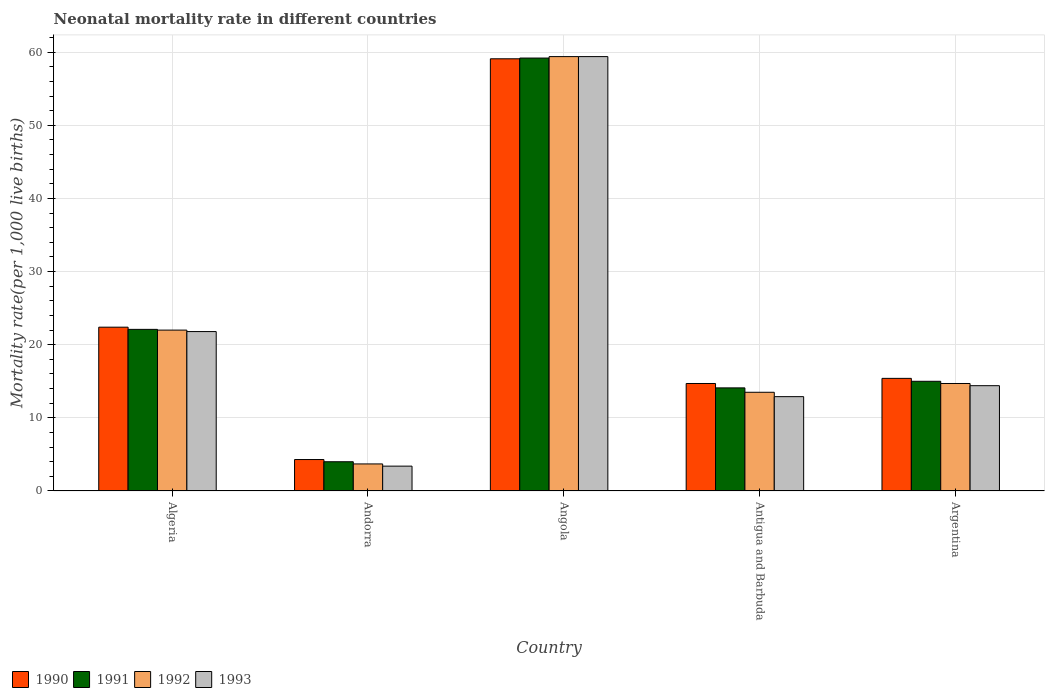How many different coloured bars are there?
Offer a very short reply. 4. How many groups of bars are there?
Offer a very short reply. 5. Are the number of bars on each tick of the X-axis equal?
Offer a very short reply. Yes. What is the label of the 1st group of bars from the left?
Make the answer very short. Algeria. What is the neonatal mortality rate in 1993 in Algeria?
Make the answer very short. 21.8. Across all countries, what is the maximum neonatal mortality rate in 1991?
Offer a very short reply. 59.2. In which country was the neonatal mortality rate in 1990 maximum?
Keep it short and to the point. Angola. In which country was the neonatal mortality rate in 1992 minimum?
Provide a succinct answer. Andorra. What is the total neonatal mortality rate in 1991 in the graph?
Offer a very short reply. 114.4. What is the difference between the neonatal mortality rate in 1992 in Algeria and that in Antigua and Barbuda?
Ensure brevity in your answer.  8.5. What is the difference between the neonatal mortality rate in 1993 in Angola and the neonatal mortality rate in 1992 in Antigua and Barbuda?
Your response must be concise. 45.9. What is the average neonatal mortality rate in 1993 per country?
Your response must be concise. 22.38. What is the difference between the neonatal mortality rate of/in 1990 and neonatal mortality rate of/in 1992 in Andorra?
Offer a terse response. 0.6. What is the ratio of the neonatal mortality rate in 1990 in Algeria to that in Andorra?
Provide a succinct answer. 5.21. Is the neonatal mortality rate in 1993 in Algeria less than that in Andorra?
Make the answer very short. No. Is the difference between the neonatal mortality rate in 1990 in Andorra and Antigua and Barbuda greater than the difference between the neonatal mortality rate in 1992 in Andorra and Antigua and Barbuda?
Your answer should be compact. No. What is the difference between the highest and the second highest neonatal mortality rate in 1993?
Ensure brevity in your answer.  37.6. What is the difference between the highest and the lowest neonatal mortality rate in 1992?
Make the answer very short. 55.7. What does the 1st bar from the left in Antigua and Barbuda represents?
Your answer should be very brief. 1990. What does the 2nd bar from the right in Angola represents?
Offer a terse response. 1992. How many bars are there?
Provide a succinct answer. 20. Are all the bars in the graph horizontal?
Make the answer very short. No. Are the values on the major ticks of Y-axis written in scientific E-notation?
Give a very brief answer. No. Does the graph contain any zero values?
Ensure brevity in your answer.  No. Does the graph contain grids?
Your response must be concise. Yes. How many legend labels are there?
Offer a terse response. 4. What is the title of the graph?
Ensure brevity in your answer.  Neonatal mortality rate in different countries. What is the label or title of the Y-axis?
Provide a short and direct response. Mortality rate(per 1,0 live births). What is the Mortality rate(per 1,000 live births) of 1990 in Algeria?
Give a very brief answer. 22.4. What is the Mortality rate(per 1,000 live births) of 1991 in Algeria?
Offer a very short reply. 22.1. What is the Mortality rate(per 1,000 live births) of 1993 in Algeria?
Offer a very short reply. 21.8. What is the Mortality rate(per 1,000 live births) of 1990 in Andorra?
Offer a very short reply. 4.3. What is the Mortality rate(per 1,000 live births) of 1990 in Angola?
Make the answer very short. 59.1. What is the Mortality rate(per 1,000 live births) of 1991 in Angola?
Your answer should be compact. 59.2. What is the Mortality rate(per 1,000 live births) of 1992 in Angola?
Your answer should be very brief. 59.4. What is the Mortality rate(per 1,000 live births) of 1993 in Angola?
Keep it short and to the point. 59.4. What is the Mortality rate(per 1,000 live births) in 1993 in Antigua and Barbuda?
Your answer should be compact. 12.9. What is the Mortality rate(per 1,000 live births) of 1991 in Argentina?
Provide a short and direct response. 15. What is the Mortality rate(per 1,000 live births) in 1993 in Argentina?
Your answer should be compact. 14.4. Across all countries, what is the maximum Mortality rate(per 1,000 live births) in 1990?
Your answer should be very brief. 59.1. Across all countries, what is the maximum Mortality rate(per 1,000 live births) in 1991?
Provide a short and direct response. 59.2. Across all countries, what is the maximum Mortality rate(per 1,000 live births) in 1992?
Your answer should be compact. 59.4. Across all countries, what is the maximum Mortality rate(per 1,000 live births) of 1993?
Offer a terse response. 59.4. Across all countries, what is the minimum Mortality rate(per 1,000 live births) of 1990?
Give a very brief answer. 4.3. Across all countries, what is the minimum Mortality rate(per 1,000 live births) of 1992?
Offer a very short reply. 3.7. What is the total Mortality rate(per 1,000 live births) of 1990 in the graph?
Provide a succinct answer. 115.9. What is the total Mortality rate(per 1,000 live births) in 1991 in the graph?
Your answer should be compact. 114.4. What is the total Mortality rate(per 1,000 live births) in 1992 in the graph?
Your answer should be compact. 113.3. What is the total Mortality rate(per 1,000 live births) in 1993 in the graph?
Provide a succinct answer. 111.9. What is the difference between the Mortality rate(per 1,000 live births) in 1990 in Algeria and that in Andorra?
Make the answer very short. 18.1. What is the difference between the Mortality rate(per 1,000 live births) in 1991 in Algeria and that in Andorra?
Offer a terse response. 18.1. What is the difference between the Mortality rate(per 1,000 live births) of 1993 in Algeria and that in Andorra?
Your answer should be very brief. 18.4. What is the difference between the Mortality rate(per 1,000 live births) in 1990 in Algeria and that in Angola?
Your answer should be compact. -36.7. What is the difference between the Mortality rate(per 1,000 live births) of 1991 in Algeria and that in Angola?
Provide a succinct answer. -37.1. What is the difference between the Mortality rate(per 1,000 live births) of 1992 in Algeria and that in Angola?
Give a very brief answer. -37.4. What is the difference between the Mortality rate(per 1,000 live births) in 1993 in Algeria and that in Angola?
Your answer should be compact. -37.6. What is the difference between the Mortality rate(per 1,000 live births) of 1991 in Algeria and that in Antigua and Barbuda?
Keep it short and to the point. 8. What is the difference between the Mortality rate(per 1,000 live births) of 1993 in Algeria and that in Antigua and Barbuda?
Your response must be concise. 8.9. What is the difference between the Mortality rate(per 1,000 live births) of 1992 in Algeria and that in Argentina?
Keep it short and to the point. 7.3. What is the difference between the Mortality rate(per 1,000 live births) in 1990 in Andorra and that in Angola?
Ensure brevity in your answer.  -54.8. What is the difference between the Mortality rate(per 1,000 live births) of 1991 in Andorra and that in Angola?
Give a very brief answer. -55.2. What is the difference between the Mortality rate(per 1,000 live births) in 1992 in Andorra and that in Angola?
Your response must be concise. -55.7. What is the difference between the Mortality rate(per 1,000 live births) in 1993 in Andorra and that in Angola?
Make the answer very short. -56. What is the difference between the Mortality rate(per 1,000 live births) in 1990 in Andorra and that in Antigua and Barbuda?
Your answer should be compact. -10.4. What is the difference between the Mortality rate(per 1,000 live births) of 1991 in Andorra and that in Antigua and Barbuda?
Your response must be concise. -10.1. What is the difference between the Mortality rate(per 1,000 live births) in 1993 in Andorra and that in Antigua and Barbuda?
Provide a succinct answer. -9.5. What is the difference between the Mortality rate(per 1,000 live births) of 1990 in Andorra and that in Argentina?
Provide a short and direct response. -11.1. What is the difference between the Mortality rate(per 1,000 live births) in 1993 in Andorra and that in Argentina?
Give a very brief answer. -11. What is the difference between the Mortality rate(per 1,000 live births) in 1990 in Angola and that in Antigua and Barbuda?
Provide a succinct answer. 44.4. What is the difference between the Mortality rate(per 1,000 live births) in 1991 in Angola and that in Antigua and Barbuda?
Offer a very short reply. 45.1. What is the difference between the Mortality rate(per 1,000 live births) in 1992 in Angola and that in Antigua and Barbuda?
Your response must be concise. 45.9. What is the difference between the Mortality rate(per 1,000 live births) of 1993 in Angola and that in Antigua and Barbuda?
Make the answer very short. 46.5. What is the difference between the Mortality rate(per 1,000 live births) of 1990 in Angola and that in Argentina?
Provide a succinct answer. 43.7. What is the difference between the Mortality rate(per 1,000 live births) of 1991 in Angola and that in Argentina?
Your answer should be compact. 44.2. What is the difference between the Mortality rate(per 1,000 live births) in 1992 in Angola and that in Argentina?
Give a very brief answer. 44.7. What is the difference between the Mortality rate(per 1,000 live births) in 1991 in Antigua and Barbuda and that in Argentina?
Provide a short and direct response. -0.9. What is the difference between the Mortality rate(per 1,000 live births) of 1993 in Antigua and Barbuda and that in Argentina?
Your answer should be very brief. -1.5. What is the difference between the Mortality rate(per 1,000 live births) in 1990 in Algeria and the Mortality rate(per 1,000 live births) in 1991 in Andorra?
Your answer should be very brief. 18.4. What is the difference between the Mortality rate(per 1,000 live births) of 1991 in Algeria and the Mortality rate(per 1,000 live births) of 1993 in Andorra?
Give a very brief answer. 18.7. What is the difference between the Mortality rate(per 1,000 live births) of 1990 in Algeria and the Mortality rate(per 1,000 live births) of 1991 in Angola?
Your answer should be compact. -36.8. What is the difference between the Mortality rate(per 1,000 live births) in 1990 in Algeria and the Mortality rate(per 1,000 live births) in 1992 in Angola?
Make the answer very short. -37. What is the difference between the Mortality rate(per 1,000 live births) of 1990 in Algeria and the Mortality rate(per 1,000 live births) of 1993 in Angola?
Your response must be concise. -37. What is the difference between the Mortality rate(per 1,000 live births) in 1991 in Algeria and the Mortality rate(per 1,000 live births) in 1992 in Angola?
Ensure brevity in your answer.  -37.3. What is the difference between the Mortality rate(per 1,000 live births) of 1991 in Algeria and the Mortality rate(per 1,000 live births) of 1993 in Angola?
Provide a succinct answer. -37.3. What is the difference between the Mortality rate(per 1,000 live births) in 1992 in Algeria and the Mortality rate(per 1,000 live births) in 1993 in Angola?
Your answer should be very brief. -37.4. What is the difference between the Mortality rate(per 1,000 live births) of 1991 in Algeria and the Mortality rate(per 1,000 live births) of 1993 in Antigua and Barbuda?
Offer a terse response. 9.2. What is the difference between the Mortality rate(per 1,000 live births) in 1992 in Algeria and the Mortality rate(per 1,000 live births) in 1993 in Antigua and Barbuda?
Give a very brief answer. 9.1. What is the difference between the Mortality rate(per 1,000 live births) in 1990 in Algeria and the Mortality rate(per 1,000 live births) in 1991 in Argentina?
Provide a succinct answer. 7.4. What is the difference between the Mortality rate(per 1,000 live births) of 1990 in Algeria and the Mortality rate(per 1,000 live births) of 1993 in Argentina?
Your response must be concise. 8. What is the difference between the Mortality rate(per 1,000 live births) in 1991 in Algeria and the Mortality rate(per 1,000 live births) in 1993 in Argentina?
Give a very brief answer. 7.7. What is the difference between the Mortality rate(per 1,000 live births) in 1992 in Algeria and the Mortality rate(per 1,000 live births) in 1993 in Argentina?
Keep it short and to the point. 7.6. What is the difference between the Mortality rate(per 1,000 live births) in 1990 in Andorra and the Mortality rate(per 1,000 live births) in 1991 in Angola?
Provide a short and direct response. -54.9. What is the difference between the Mortality rate(per 1,000 live births) in 1990 in Andorra and the Mortality rate(per 1,000 live births) in 1992 in Angola?
Keep it short and to the point. -55.1. What is the difference between the Mortality rate(per 1,000 live births) in 1990 in Andorra and the Mortality rate(per 1,000 live births) in 1993 in Angola?
Provide a succinct answer. -55.1. What is the difference between the Mortality rate(per 1,000 live births) in 1991 in Andorra and the Mortality rate(per 1,000 live births) in 1992 in Angola?
Your response must be concise. -55.4. What is the difference between the Mortality rate(per 1,000 live births) of 1991 in Andorra and the Mortality rate(per 1,000 live births) of 1993 in Angola?
Give a very brief answer. -55.4. What is the difference between the Mortality rate(per 1,000 live births) in 1992 in Andorra and the Mortality rate(per 1,000 live births) in 1993 in Angola?
Give a very brief answer. -55.7. What is the difference between the Mortality rate(per 1,000 live births) of 1990 in Andorra and the Mortality rate(per 1,000 live births) of 1993 in Antigua and Barbuda?
Make the answer very short. -8.6. What is the difference between the Mortality rate(per 1,000 live births) in 1992 in Andorra and the Mortality rate(per 1,000 live births) in 1993 in Antigua and Barbuda?
Offer a terse response. -9.2. What is the difference between the Mortality rate(per 1,000 live births) of 1991 in Andorra and the Mortality rate(per 1,000 live births) of 1992 in Argentina?
Your answer should be very brief. -10.7. What is the difference between the Mortality rate(per 1,000 live births) in 1991 in Andorra and the Mortality rate(per 1,000 live births) in 1993 in Argentina?
Your answer should be compact. -10.4. What is the difference between the Mortality rate(per 1,000 live births) in 1992 in Andorra and the Mortality rate(per 1,000 live births) in 1993 in Argentina?
Offer a terse response. -10.7. What is the difference between the Mortality rate(per 1,000 live births) in 1990 in Angola and the Mortality rate(per 1,000 live births) in 1991 in Antigua and Barbuda?
Make the answer very short. 45. What is the difference between the Mortality rate(per 1,000 live births) in 1990 in Angola and the Mortality rate(per 1,000 live births) in 1992 in Antigua and Barbuda?
Your answer should be compact. 45.6. What is the difference between the Mortality rate(per 1,000 live births) in 1990 in Angola and the Mortality rate(per 1,000 live births) in 1993 in Antigua and Barbuda?
Provide a succinct answer. 46.2. What is the difference between the Mortality rate(per 1,000 live births) in 1991 in Angola and the Mortality rate(per 1,000 live births) in 1992 in Antigua and Barbuda?
Ensure brevity in your answer.  45.7. What is the difference between the Mortality rate(per 1,000 live births) of 1991 in Angola and the Mortality rate(per 1,000 live births) of 1993 in Antigua and Barbuda?
Make the answer very short. 46.3. What is the difference between the Mortality rate(per 1,000 live births) of 1992 in Angola and the Mortality rate(per 1,000 live births) of 1993 in Antigua and Barbuda?
Your response must be concise. 46.5. What is the difference between the Mortality rate(per 1,000 live births) of 1990 in Angola and the Mortality rate(per 1,000 live births) of 1991 in Argentina?
Give a very brief answer. 44.1. What is the difference between the Mortality rate(per 1,000 live births) in 1990 in Angola and the Mortality rate(per 1,000 live births) in 1992 in Argentina?
Make the answer very short. 44.4. What is the difference between the Mortality rate(per 1,000 live births) in 1990 in Angola and the Mortality rate(per 1,000 live births) in 1993 in Argentina?
Your response must be concise. 44.7. What is the difference between the Mortality rate(per 1,000 live births) of 1991 in Angola and the Mortality rate(per 1,000 live births) of 1992 in Argentina?
Ensure brevity in your answer.  44.5. What is the difference between the Mortality rate(per 1,000 live births) in 1991 in Angola and the Mortality rate(per 1,000 live births) in 1993 in Argentina?
Your response must be concise. 44.8. What is the difference between the Mortality rate(per 1,000 live births) in 1992 in Angola and the Mortality rate(per 1,000 live births) in 1993 in Argentina?
Your response must be concise. 45. What is the difference between the Mortality rate(per 1,000 live births) in 1990 in Antigua and Barbuda and the Mortality rate(per 1,000 live births) in 1991 in Argentina?
Give a very brief answer. -0.3. What is the difference between the Mortality rate(per 1,000 live births) of 1990 in Antigua and Barbuda and the Mortality rate(per 1,000 live births) of 1993 in Argentina?
Offer a very short reply. 0.3. What is the difference between the Mortality rate(per 1,000 live births) of 1991 in Antigua and Barbuda and the Mortality rate(per 1,000 live births) of 1992 in Argentina?
Offer a very short reply. -0.6. What is the average Mortality rate(per 1,000 live births) in 1990 per country?
Make the answer very short. 23.18. What is the average Mortality rate(per 1,000 live births) of 1991 per country?
Offer a terse response. 22.88. What is the average Mortality rate(per 1,000 live births) of 1992 per country?
Your response must be concise. 22.66. What is the average Mortality rate(per 1,000 live births) of 1993 per country?
Your answer should be very brief. 22.38. What is the difference between the Mortality rate(per 1,000 live births) in 1990 and Mortality rate(per 1,000 live births) in 1992 in Algeria?
Your response must be concise. 0.4. What is the difference between the Mortality rate(per 1,000 live births) in 1990 and Mortality rate(per 1,000 live births) in 1993 in Algeria?
Your answer should be very brief. 0.6. What is the difference between the Mortality rate(per 1,000 live births) in 1990 and Mortality rate(per 1,000 live births) in 1991 in Andorra?
Make the answer very short. 0.3. What is the difference between the Mortality rate(per 1,000 live births) in 1990 and Mortality rate(per 1,000 live births) in 1992 in Andorra?
Provide a short and direct response. 0.6. What is the difference between the Mortality rate(per 1,000 live births) of 1990 and Mortality rate(per 1,000 live births) of 1992 in Angola?
Your answer should be compact. -0.3. What is the difference between the Mortality rate(per 1,000 live births) in 1991 and Mortality rate(per 1,000 live births) in 1993 in Angola?
Your answer should be very brief. -0.2. What is the difference between the Mortality rate(per 1,000 live births) in 1992 and Mortality rate(per 1,000 live births) in 1993 in Angola?
Provide a succinct answer. 0. What is the difference between the Mortality rate(per 1,000 live births) of 1990 and Mortality rate(per 1,000 live births) of 1993 in Antigua and Barbuda?
Offer a terse response. 1.8. What is the difference between the Mortality rate(per 1,000 live births) in 1991 and Mortality rate(per 1,000 live births) in 1992 in Antigua and Barbuda?
Your answer should be very brief. 0.6. What is the difference between the Mortality rate(per 1,000 live births) of 1991 and Mortality rate(per 1,000 live births) of 1993 in Antigua and Barbuda?
Make the answer very short. 1.2. What is the difference between the Mortality rate(per 1,000 live births) in 1992 and Mortality rate(per 1,000 live births) in 1993 in Antigua and Barbuda?
Your response must be concise. 0.6. What is the difference between the Mortality rate(per 1,000 live births) of 1990 and Mortality rate(per 1,000 live births) of 1991 in Argentina?
Your response must be concise. 0.4. What is the difference between the Mortality rate(per 1,000 live births) in 1990 and Mortality rate(per 1,000 live births) in 1993 in Argentina?
Your answer should be compact. 1. What is the difference between the Mortality rate(per 1,000 live births) in 1992 and Mortality rate(per 1,000 live births) in 1993 in Argentina?
Give a very brief answer. 0.3. What is the ratio of the Mortality rate(per 1,000 live births) in 1990 in Algeria to that in Andorra?
Provide a short and direct response. 5.21. What is the ratio of the Mortality rate(per 1,000 live births) in 1991 in Algeria to that in Andorra?
Ensure brevity in your answer.  5.53. What is the ratio of the Mortality rate(per 1,000 live births) of 1992 in Algeria to that in Andorra?
Your answer should be very brief. 5.95. What is the ratio of the Mortality rate(per 1,000 live births) in 1993 in Algeria to that in Andorra?
Provide a succinct answer. 6.41. What is the ratio of the Mortality rate(per 1,000 live births) in 1990 in Algeria to that in Angola?
Offer a very short reply. 0.38. What is the ratio of the Mortality rate(per 1,000 live births) in 1991 in Algeria to that in Angola?
Your answer should be compact. 0.37. What is the ratio of the Mortality rate(per 1,000 live births) of 1992 in Algeria to that in Angola?
Give a very brief answer. 0.37. What is the ratio of the Mortality rate(per 1,000 live births) of 1993 in Algeria to that in Angola?
Your response must be concise. 0.37. What is the ratio of the Mortality rate(per 1,000 live births) of 1990 in Algeria to that in Antigua and Barbuda?
Give a very brief answer. 1.52. What is the ratio of the Mortality rate(per 1,000 live births) in 1991 in Algeria to that in Antigua and Barbuda?
Keep it short and to the point. 1.57. What is the ratio of the Mortality rate(per 1,000 live births) in 1992 in Algeria to that in Antigua and Barbuda?
Provide a succinct answer. 1.63. What is the ratio of the Mortality rate(per 1,000 live births) in 1993 in Algeria to that in Antigua and Barbuda?
Offer a terse response. 1.69. What is the ratio of the Mortality rate(per 1,000 live births) of 1990 in Algeria to that in Argentina?
Keep it short and to the point. 1.45. What is the ratio of the Mortality rate(per 1,000 live births) of 1991 in Algeria to that in Argentina?
Offer a very short reply. 1.47. What is the ratio of the Mortality rate(per 1,000 live births) in 1992 in Algeria to that in Argentina?
Your response must be concise. 1.5. What is the ratio of the Mortality rate(per 1,000 live births) of 1993 in Algeria to that in Argentina?
Keep it short and to the point. 1.51. What is the ratio of the Mortality rate(per 1,000 live births) of 1990 in Andorra to that in Angola?
Your answer should be very brief. 0.07. What is the ratio of the Mortality rate(per 1,000 live births) in 1991 in Andorra to that in Angola?
Your response must be concise. 0.07. What is the ratio of the Mortality rate(per 1,000 live births) in 1992 in Andorra to that in Angola?
Keep it short and to the point. 0.06. What is the ratio of the Mortality rate(per 1,000 live births) in 1993 in Andorra to that in Angola?
Your response must be concise. 0.06. What is the ratio of the Mortality rate(per 1,000 live births) in 1990 in Andorra to that in Antigua and Barbuda?
Make the answer very short. 0.29. What is the ratio of the Mortality rate(per 1,000 live births) of 1991 in Andorra to that in Antigua and Barbuda?
Offer a very short reply. 0.28. What is the ratio of the Mortality rate(per 1,000 live births) in 1992 in Andorra to that in Antigua and Barbuda?
Offer a terse response. 0.27. What is the ratio of the Mortality rate(per 1,000 live births) in 1993 in Andorra to that in Antigua and Barbuda?
Ensure brevity in your answer.  0.26. What is the ratio of the Mortality rate(per 1,000 live births) in 1990 in Andorra to that in Argentina?
Ensure brevity in your answer.  0.28. What is the ratio of the Mortality rate(per 1,000 live births) of 1991 in Andorra to that in Argentina?
Offer a terse response. 0.27. What is the ratio of the Mortality rate(per 1,000 live births) of 1992 in Andorra to that in Argentina?
Your response must be concise. 0.25. What is the ratio of the Mortality rate(per 1,000 live births) of 1993 in Andorra to that in Argentina?
Offer a very short reply. 0.24. What is the ratio of the Mortality rate(per 1,000 live births) in 1990 in Angola to that in Antigua and Barbuda?
Keep it short and to the point. 4.02. What is the ratio of the Mortality rate(per 1,000 live births) in 1991 in Angola to that in Antigua and Barbuda?
Keep it short and to the point. 4.2. What is the ratio of the Mortality rate(per 1,000 live births) in 1993 in Angola to that in Antigua and Barbuda?
Your answer should be very brief. 4.6. What is the ratio of the Mortality rate(per 1,000 live births) of 1990 in Angola to that in Argentina?
Offer a very short reply. 3.84. What is the ratio of the Mortality rate(per 1,000 live births) of 1991 in Angola to that in Argentina?
Your answer should be very brief. 3.95. What is the ratio of the Mortality rate(per 1,000 live births) of 1992 in Angola to that in Argentina?
Keep it short and to the point. 4.04. What is the ratio of the Mortality rate(per 1,000 live births) in 1993 in Angola to that in Argentina?
Your response must be concise. 4.12. What is the ratio of the Mortality rate(per 1,000 live births) in 1990 in Antigua and Barbuda to that in Argentina?
Provide a succinct answer. 0.95. What is the ratio of the Mortality rate(per 1,000 live births) of 1992 in Antigua and Barbuda to that in Argentina?
Your answer should be compact. 0.92. What is the ratio of the Mortality rate(per 1,000 live births) of 1993 in Antigua and Barbuda to that in Argentina?
Your answer should be very brief. 0.9. What is the difference between the highest and the second highest Mortality rate(per 1,000 live births) of 1990?
Offer a very short reply. 36.7. What is the difference between the highest and the second highest Mortality rate(per 1,000 live births) of 1991?
Your answer should be compact. 37.1. What is the difference between the highest and the second highest Mortality rate(per 1,000 live births) in 1992?
Provide a short and direct response. 37.4. What is the difference between the highest and the second highest Mortality rate(per 1,000 live births) of 1993?
Keep it short and to the point. 37.6. What is the difference between the highest and the lowest Mortality rate(per 1,000 live births) in 1990?
Your answer should be compact. 54.8. What is the difference between the highest and the lowest Mortality rate(per 1,000 live births) in 1991?
Keep it short and to the point. 55.2. What is the difference between the highest and the lowest Mortality rate(per 1,000 live births) in 1992?
Provide a short and direct response. 55.7. 